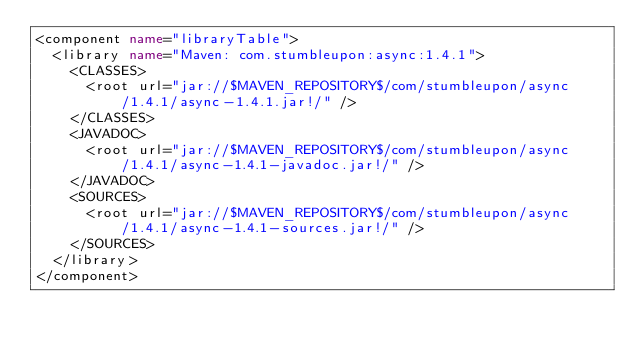Convert code to text. <code><loc_0><loc_0><loc_500><loc_500><_XML_><component name="libraryTable">
  <library name="Maven: com.stumbleupon:async:1.4.1">
    <CLASSES>
      <root url="jar://$MAVEN_REPOSITORY$/com/stumbleupon/async/1.4.1/async-1.4.1.jar!/" />
    </CLASSES>
    <JAVADOC>
      <root url="jar://$MAVEN_REPOSITORY$/com/stumbleupon/async/1.4.1/async-1.4.1-javadoc.jar!/" />
    </JAVADOC>
    <SOURCES>
      <root url="jar://$MAVEN_REPOSITORY$/com/stumbleupon/async/1.4.1/async-1.4.1-sources.jar!/" />
    </SOURCES>
  </library>
</component></code> 